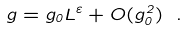Convert formula to latex. <formula><loc_0><loc_0><loc_500><loc_500>g = g _ { 0 } L ^ { \varepsilon } + O ( g _ { 0 } ^ { 2 } ) \ .</formula> 